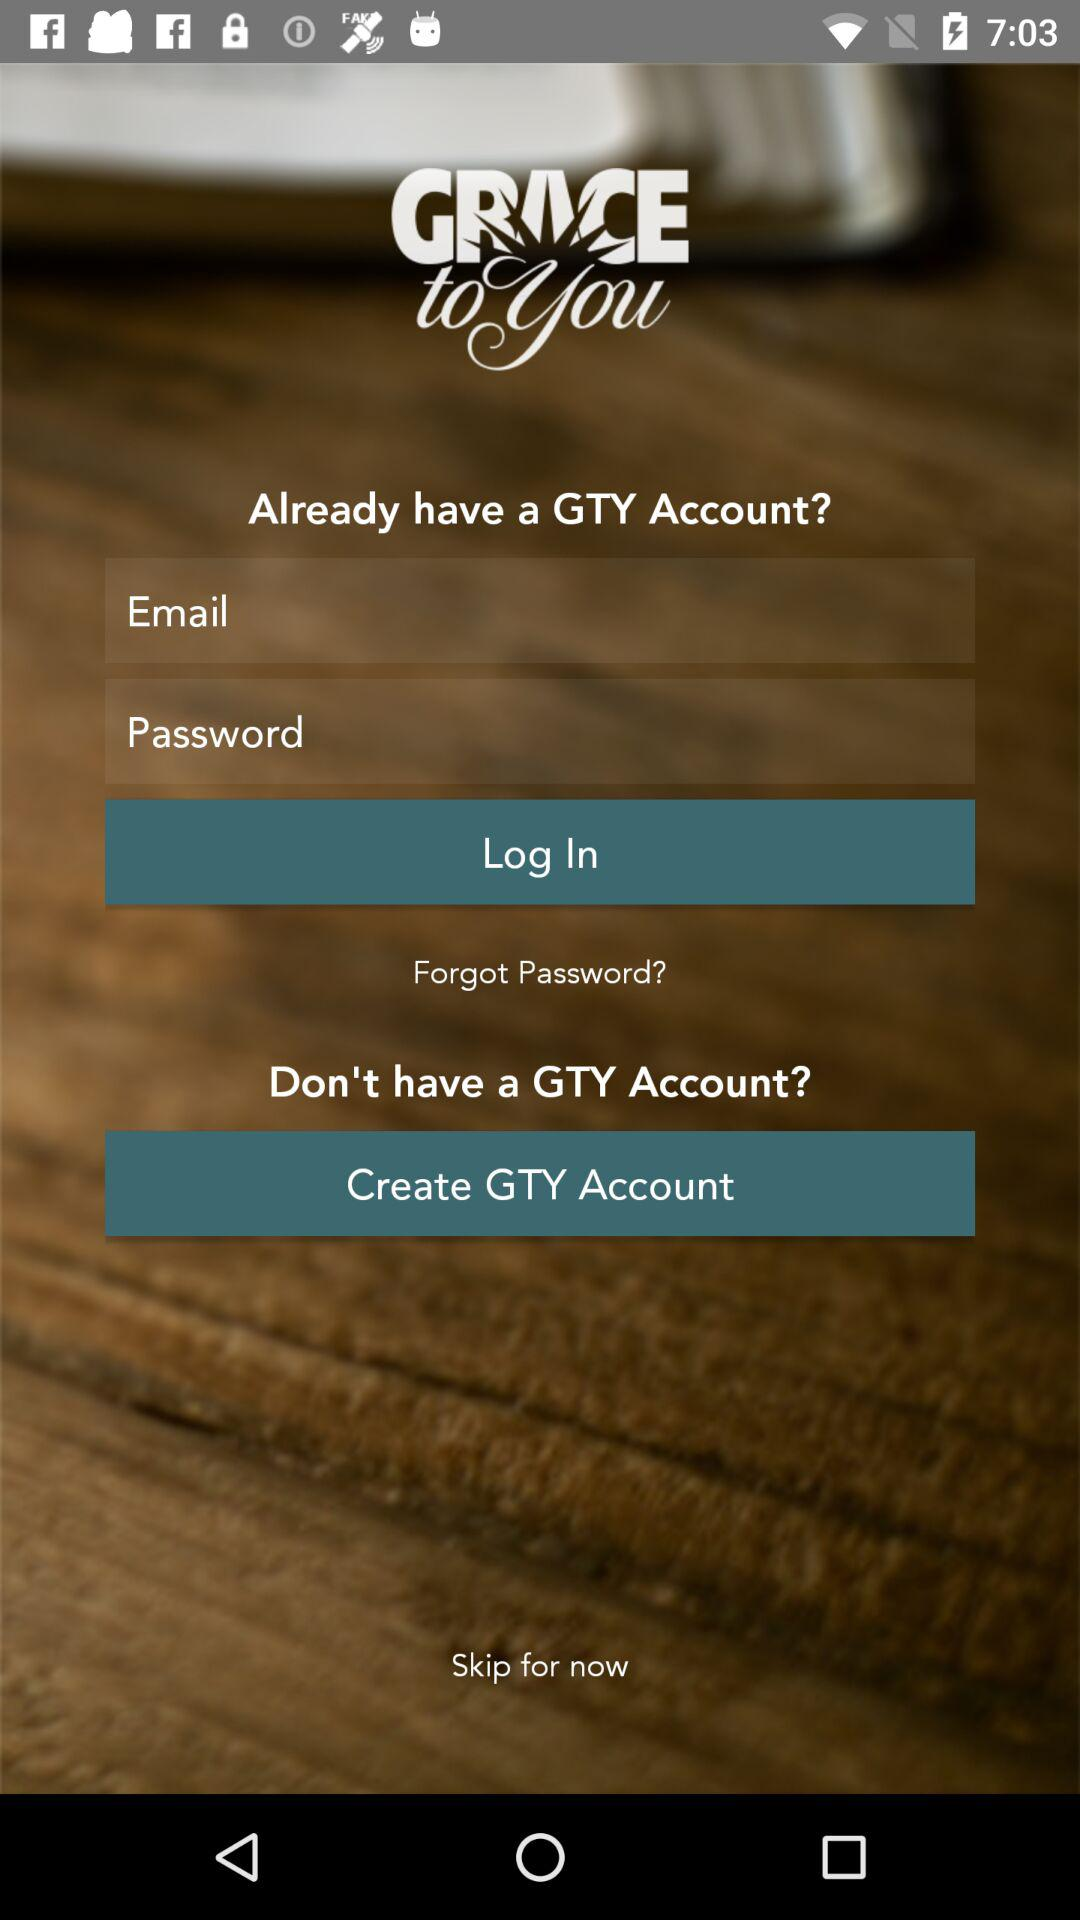How many text input fields are there on the screen?
Answer the question using a single word or phrase. 2 